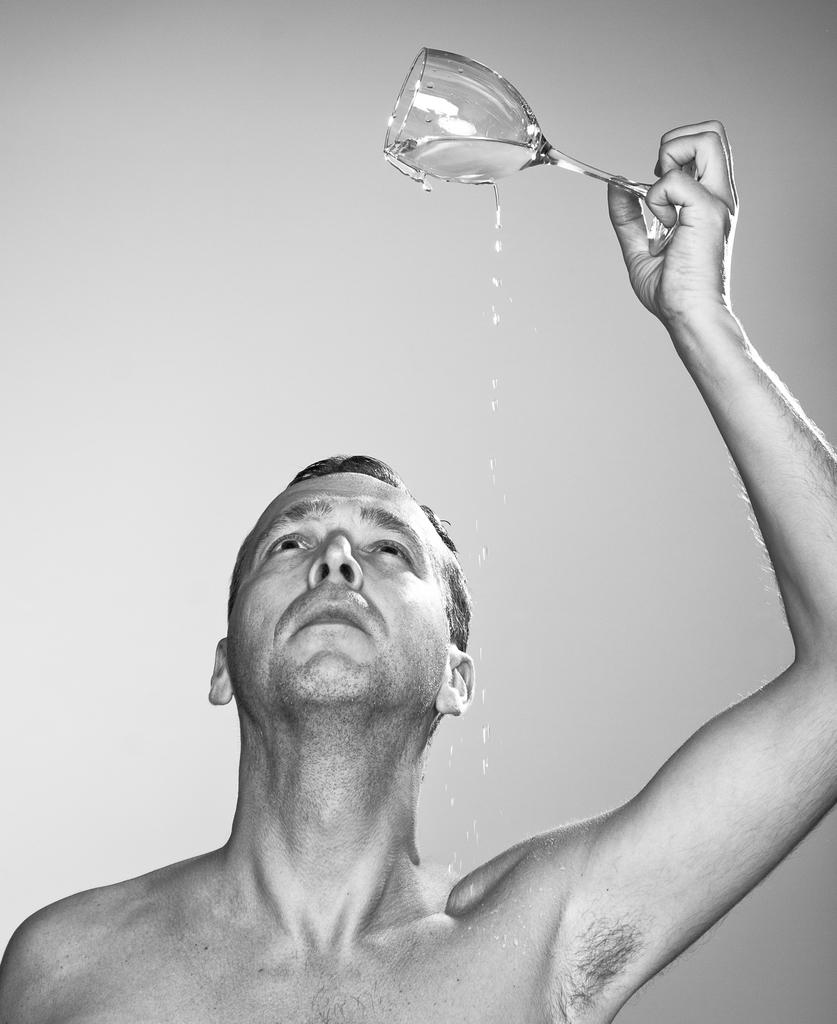Who is the person in the image? There is a man in the image. What is the man doing in the image? The man is pouring water from a glass. Is the water being poured onto the man or something else? The water is being poured onto the man. What type of fang can be seen in the image? There is no fang present in the image. What boundary is being crossed in the image? There is no boundary being crossed in the image. 